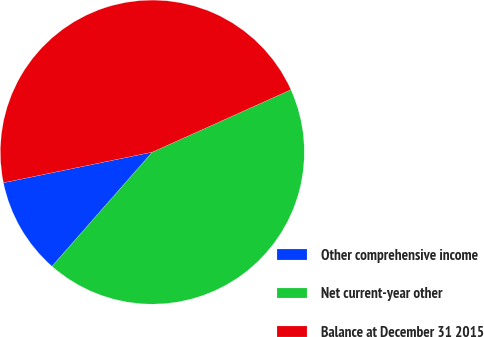<chart> <loc_0><loc_0><loc_500><loc_500><pie_chart><fcel>Other comprehensive income<fcel>Net current-year other<fcel>Balance at December 31 2015<nl><fcel>10.3%<fcel>43.2%<fcel>46.49%<nl></chart> 